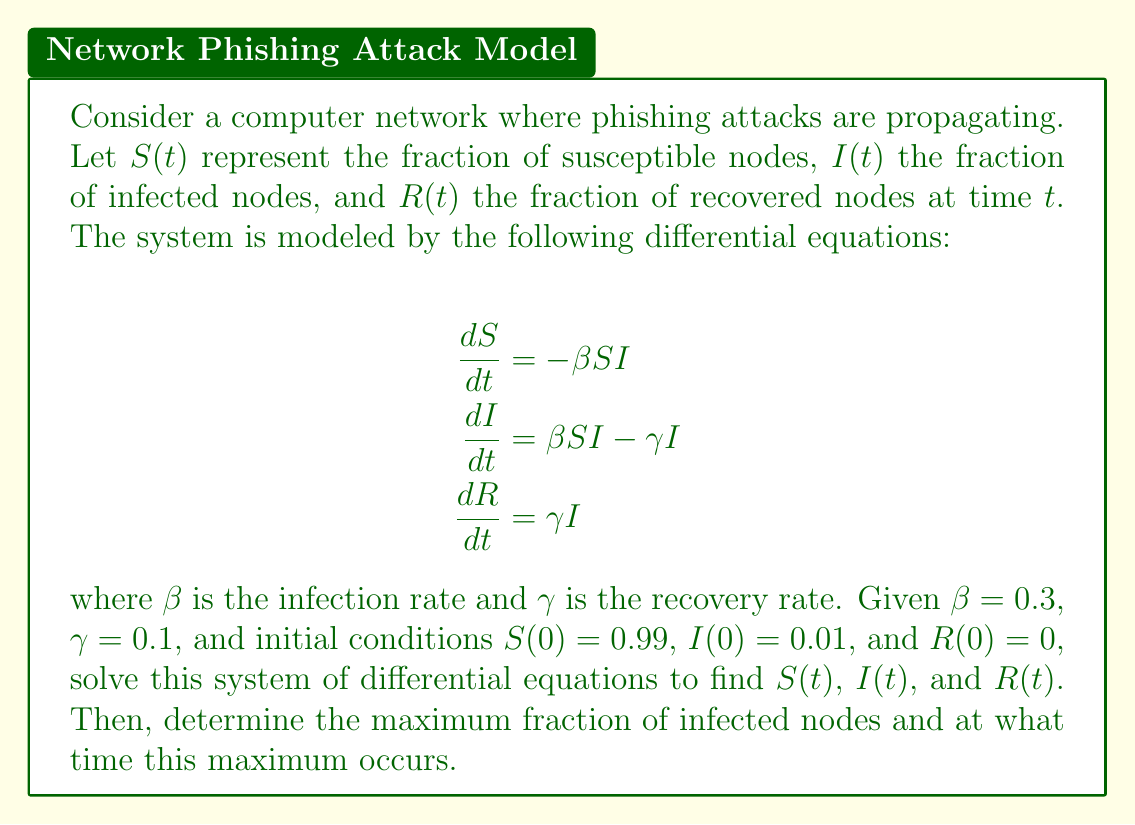Provide a solution to this math problem. To solve this system of differential equations, we'll use the SIR (Susceptible-Infected-Recovered) model approach:

1) First, we note that $S + I + R = 1$ at all times, as these represent fractions of the total population.

2) We can solve for $S$ in terms of $I$:
   $$\frac{dS}{dI} = \frac{dS/dt}{dI/dt} = \frac{-\beta S I}{\beta S I - \gamma I} = -\frac{S}{\frac{\beta}{\gamma}S - 1}$$

3) Integrating both sides:
   $$\int \frac{dS}{S} = -\int \frac{dI}{\frac{\beta}{\gamma}S - 1}$$
   $$\ln(S) = -\frac{\gamma}{\beta}\ln(\frac{\beta}{\gamma}S - 1) + C$$

4) Using the initial conditions, we can find $C$:
   $$\ln(0.99) = -\frac{0.1}{0.3}\ln(\frac{0.3}{0.1}0.99 - 1) + C$$
   $$C = \ln(0.99) + \frac{1}{3}\ln(1.97) \approx 0.2203$$

5) Therefore, the solution for $S$ in terms of $I$ is:
   $$S = e^{-\frac{\gamma}{\beta}\ln(\frac{\beta}{\gamma}S - 1) + 0.2203}$$

6) To find the maximum fraction of infected nodes, we set $\frac{dI}{dt} = 0$:
   $$0 = \beta S I - \gamma I$$
   $$S = \frac{\gamma}{\beta} = \frac{0.1}{0.3} = \frac{1}{3}$$

7) Substituting this back into the equation for $S$:
   $$\frac{1}{3} = e^{-\frac{1}{3}\ln(2) + 0.2203}$$
   $$I_{max} = 1 - S - R = 1 - \frac{1}{3} - (\frac{1}{3}\ln(2) - 0.2203) \approx 0.4176$$

8) To find the time when this maximum occurs, we can numerically solve the differential equations using methods like Runge-Kutta.
Answer: The maximum fraction of infected nodes is approximately 0.4176 or 41.76%. This occurs when $S = \frac{1}{3}$. The exact time when this maximum occurs would require numerical methods to solve, but it can be approximated using computational tools. 